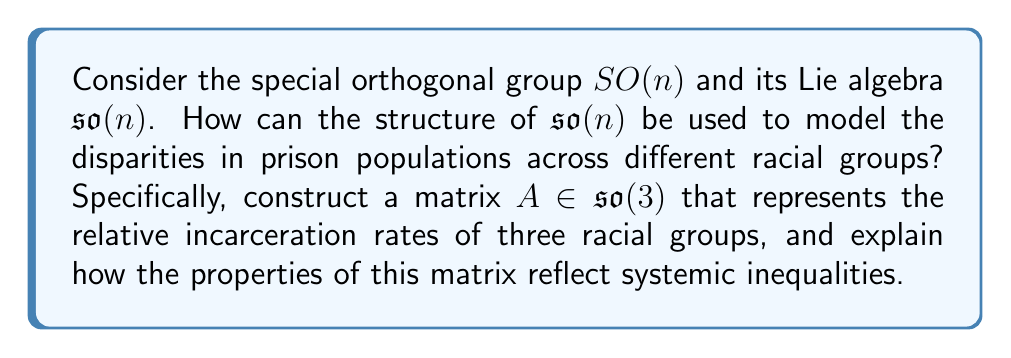What is the answer to this math problem? To approach this problem, we need to understand the structure of $\mathfrak{so}(n)$ and apply it to our socio-economic context:

1) The Lie algebra $\mathfrak{so}(n)$ of $SO(n)$ consists of all $n \times n$ skew-symmetric matrices. For $\mathfrak{so}(3)$, a general element has the form:

   $$A = \begin{pmatrix}
   0 & -a & b \\
   a & 0 & -c \\
   -b & c & 0
   \end{pmatrix}$$

   where $a$, $b$, and $c$ are real numbers.

2) In our context, we can interpret the three dimensions as representing three racial groups. The magnitude of each entry can represent the relative incarceration rate between two groups.

3) The skew-symmetry property ($A^T = -A$) ensures that if the entry $(i,j)$ represents the incarceration rate of group $i$ relative to group $j$, then the entry $(j,i)$ represents the negative of this rate, maintaining consistency.

4) Let's construct a specific example. Suppose we have data showing that:
   - Group 2 is incarcerated at 2.5 times the rate of Group 1
   - Group 3 is incarcerated at 1.8 times the rate of Group 1
   - Group 3 is incarcerated at 0.72 times the rate of Group 2

5) We can represent this as:

   $$A = \begin{pmatrix}
   0 & -2.5 & 1.8 \\
   2.5 & 0 & -0.72 \\
   -1.8 & 0.72 & 0
   \end{pmatrix}$$

6) The properties of this matrix reflect systemic inequalities:
   - The skew-symmetry shows the relational nature of disparities.
   - The magnitudes of the entries quantify the extent of disparities.
   - The structure ensures mathematical consistency in representing relative rates.

7) The Lie bracket $[A,B] = AB - BA$ for $A,B \in \mathfrak{so}(3)$ could be used to model how these disparities evolve over time or interact with other socio-economic factors.
Answer: The Lie algebra $\mathfrak{so}(3)$ matrix representing relative incarceration rates for three racial groups is:

$$A = \begin{pmatrix}
0 & -2.5 & 1.8 \\
2.5 & 0 & -0.72 \\
-1.8 & 0.72 & 0
\end{pmatrix}$$

This matrix encapsulates the systemic inequalities in incarceration rates through its skew-symmetric structure and the magnitudes of its entries. 